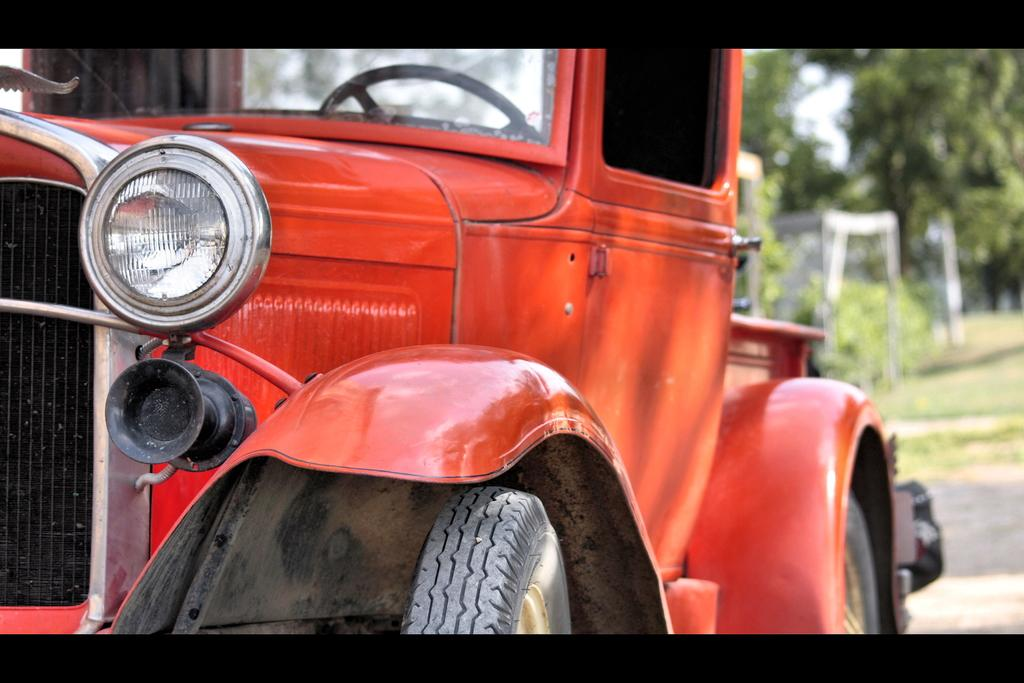What is the main subject of the image? There is a vehicle parked on the road in the image. What can be seen behind the vehicle? There are trees visible behind the vehicle. Can you describe the quality of the image? The image may be slightly blurry in the background. What is the plot of the war that is happening in the image? There is no war or plot present in the image; it features a parked vehicle and trees in the background. 